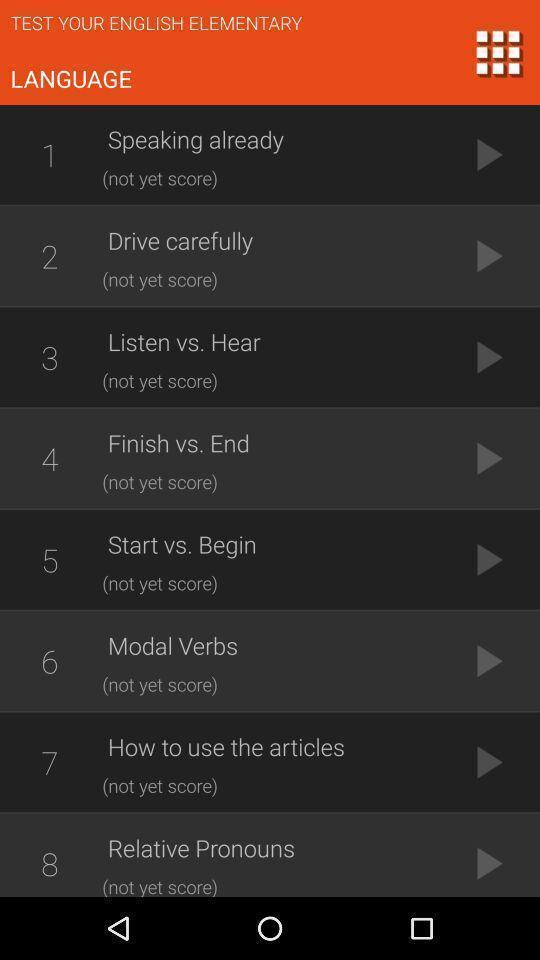Explain what's happening in this screen capture. Screen showing language. 